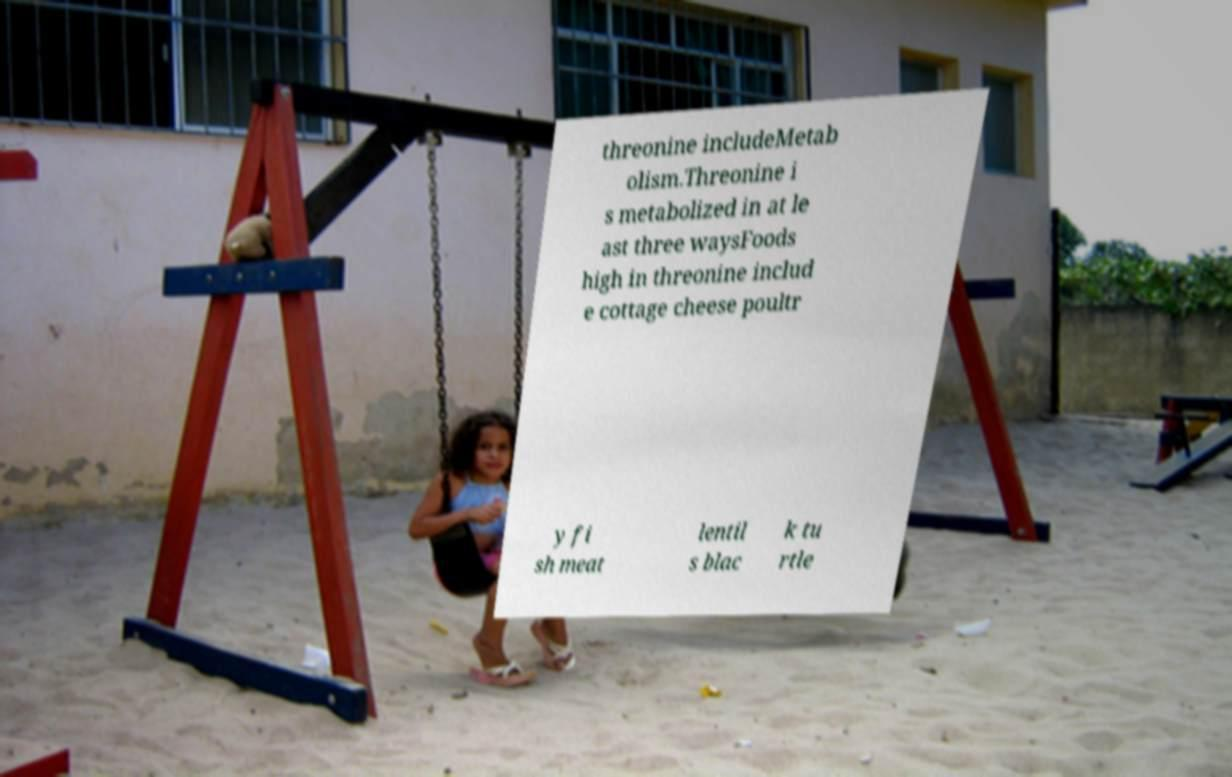There's text embedded in this image that I need extracted. Can you transcribe it verbatim? threonine includeMetab olism.Threonine i s metabolized in at le ast three waysFoods high in threonine includ e cottage cheese poultr y fi sh meat lentil s blac k tu rtle 